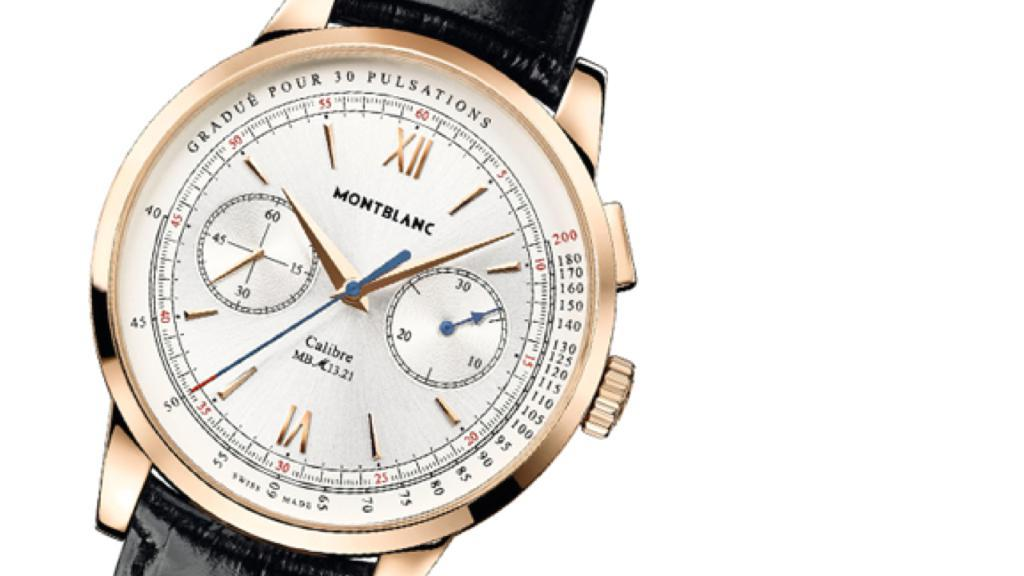<image>
Share a concise interpretation of the image provided. A gold, black, and white watch that says Montblanc. 